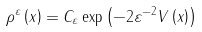Convert formula to latex. <formula><loc_0><loc_0><loc_500><loc_500>\rho ^ { \varepsilon } \left ( x \right ) = C _ { \varepsilon } \exp \left ( - 2 \varepsilon ^ { - 2 } V \left ( x \right ) \right )</formula> 